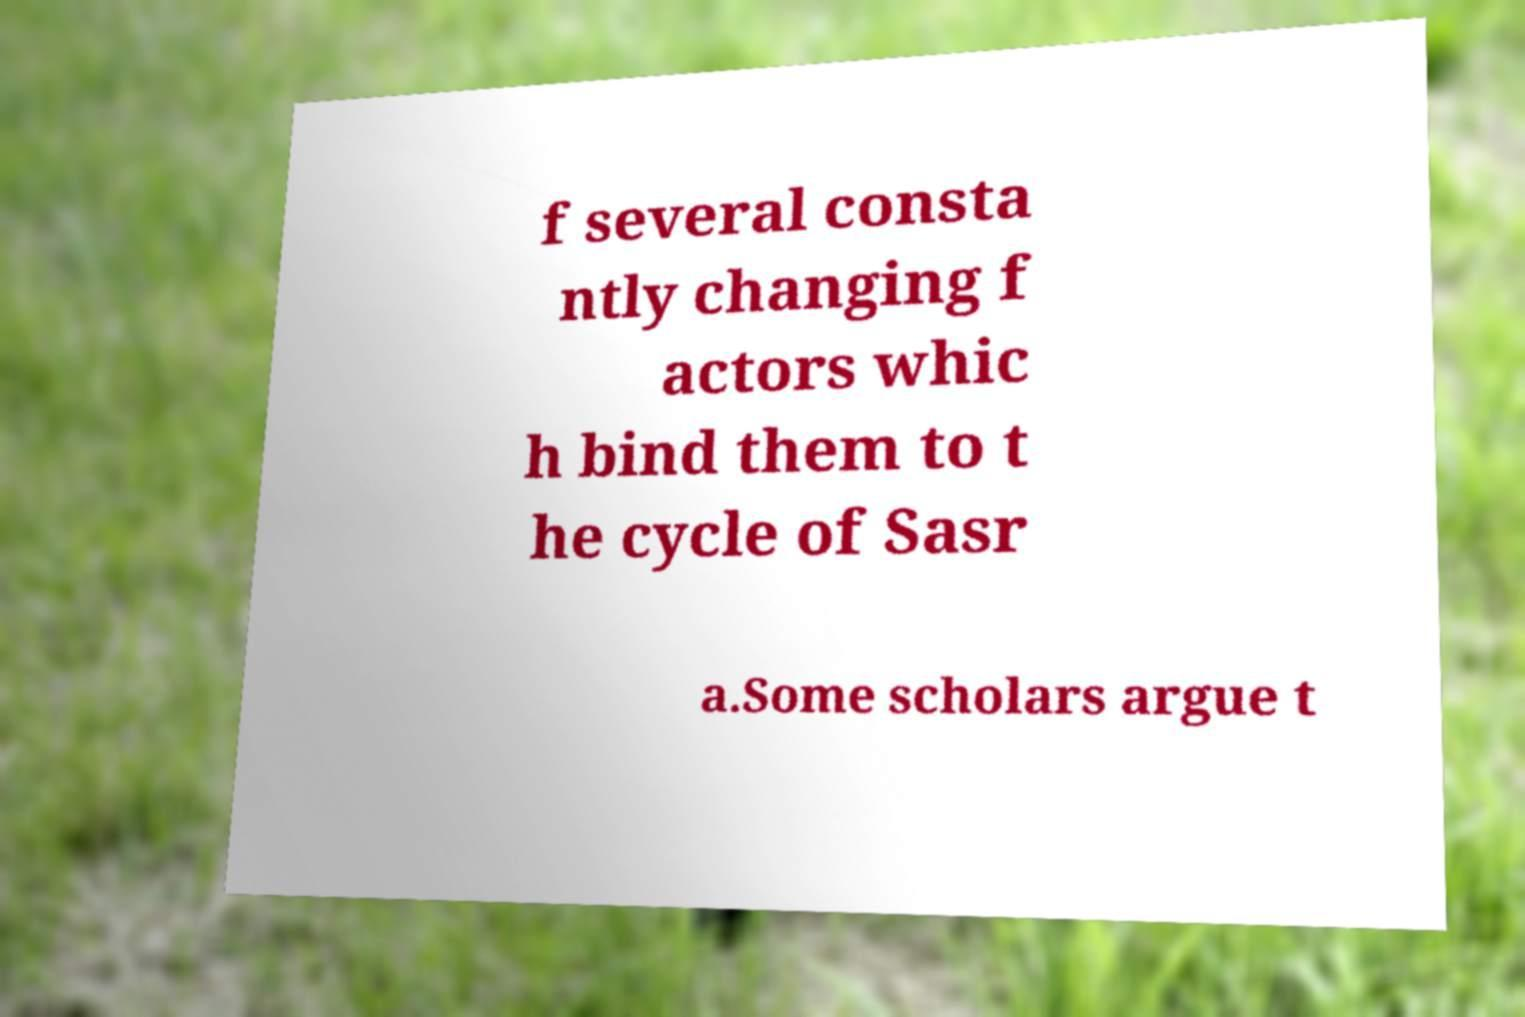I need the written content from this picture converted into text. Can you do that? f several consta ntly changing f actors whic h bind them to t he cycle of Sasr a.Some scholars argue t 